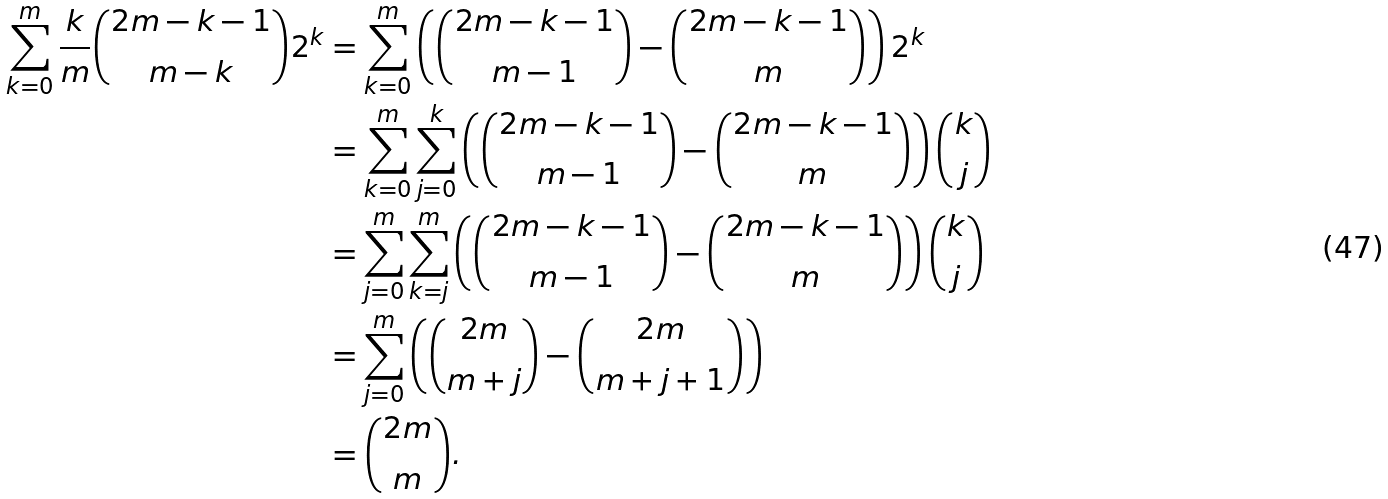<formula> <loc_0><loc_0><loc_500><loc_500>\sum _ { k = 0 } ^ { m } \frac { k } { m } \binom { 2 m - k - 1 } { m - k } 2 ^ { k } & = \sum _ { k = 0 } ^ { m } \left ( \binom { 2 m - k - 1 } { m - 1 } - \binom { 2 m - k - 1 } m \right ) 2 ^ { k } \\ & = \sum _ { k = 0 } ^ { m } \sum _ { j = 0 } ^ { k } \left ( \binom { 2 m - k - 1 } { m - 1 } - \binom { 2 m - k - 1 } m \right ) \binom { k } { j } \\ & = \sum _ { j = 0 } ^ { m } \sum _ { k = j } ^ { m } \left ( \binom { 2 m - k - 1 } { m - 1 } - \binom { 2 m - k - 1 } m \right ) \binom { k } { j } \\ & = \sum _ { j = 0 } ^ { m } \left ( \binom { 2 m } { m + j } - \binom { 2 m } { m + j + 1 } \right ) \\ & = \binom { 2 m } { m } .</formula> 